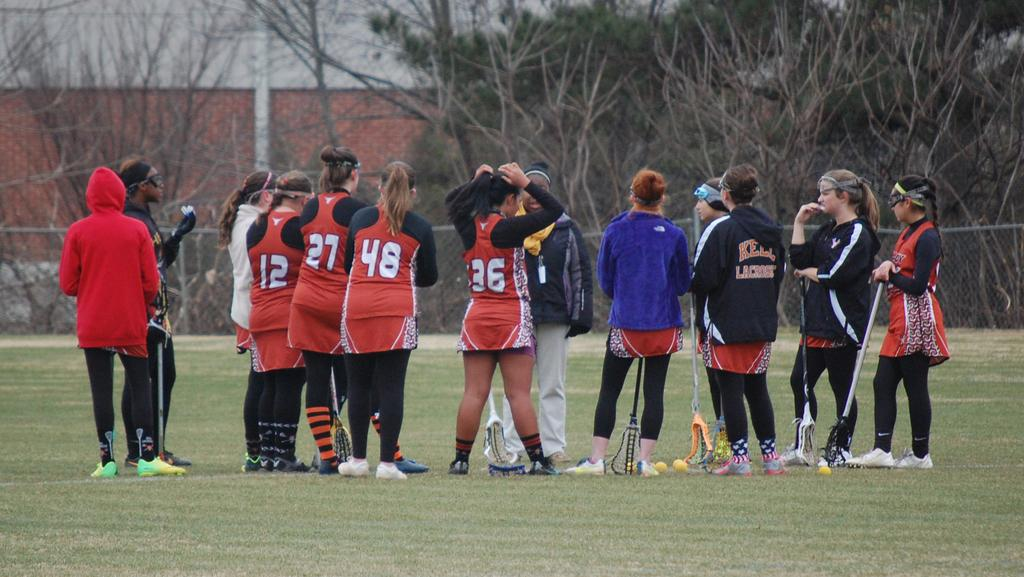What is the main subject of the image? The main subject of the image is a group of people standing in the center. What type of terrain is visible at the bottom of the image? There is grass at the bottom of the image. What can be seen in the background of the image? There is a wall, trees, a fence, and a pole in the background of the image. What type of boot is being used to lock the gate in the image? There is no gate or boot present in the image. Can you tell me how many people are wearing a lock on their head in the image? There are no locks or people wearing locks on their heads in the image. 